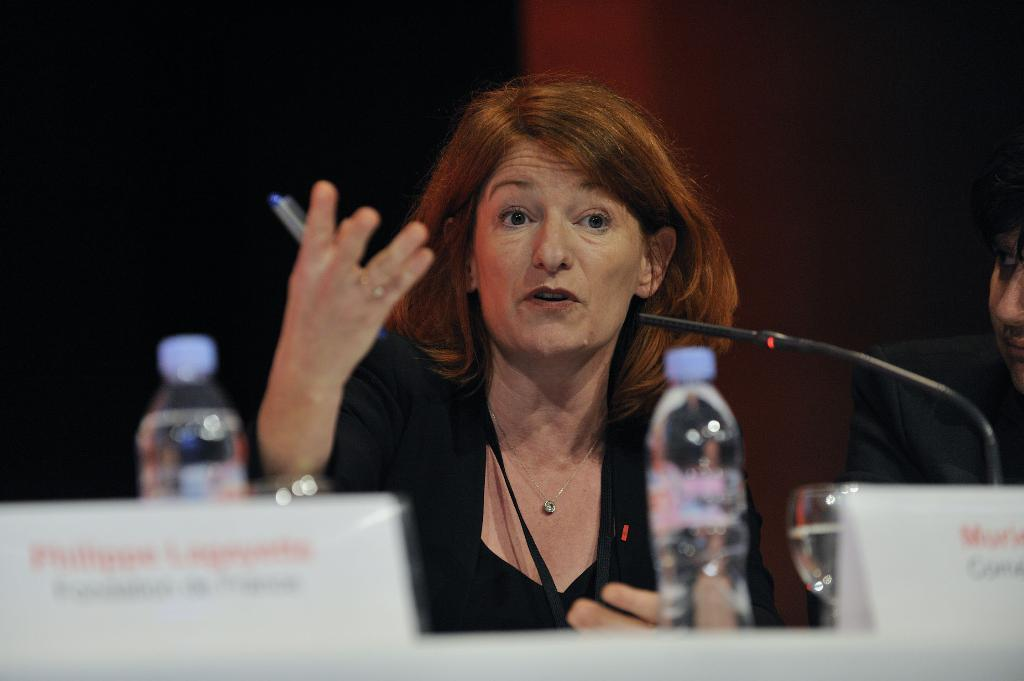Who is the main subject in the picture? There is a woman in the picture. What is the woman doing in the image? The woman is sitting and speaking. What is in front of the woman? There is a table in front of the woman. What can be seen on the table? There is a water bottle on the table. What type of stew is the woman cooking on the table in the image? There is no stew present in the image; the woman is sitting and speaking, and there is a water bottle on the table. 